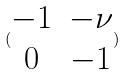Convert formula to latex. <formula><loc_0><loc_0><loc_500><loc_500>( \begin{matrix} - 1 & - \nu \\ 0 & - 1 \end{matrix} )</formula> 